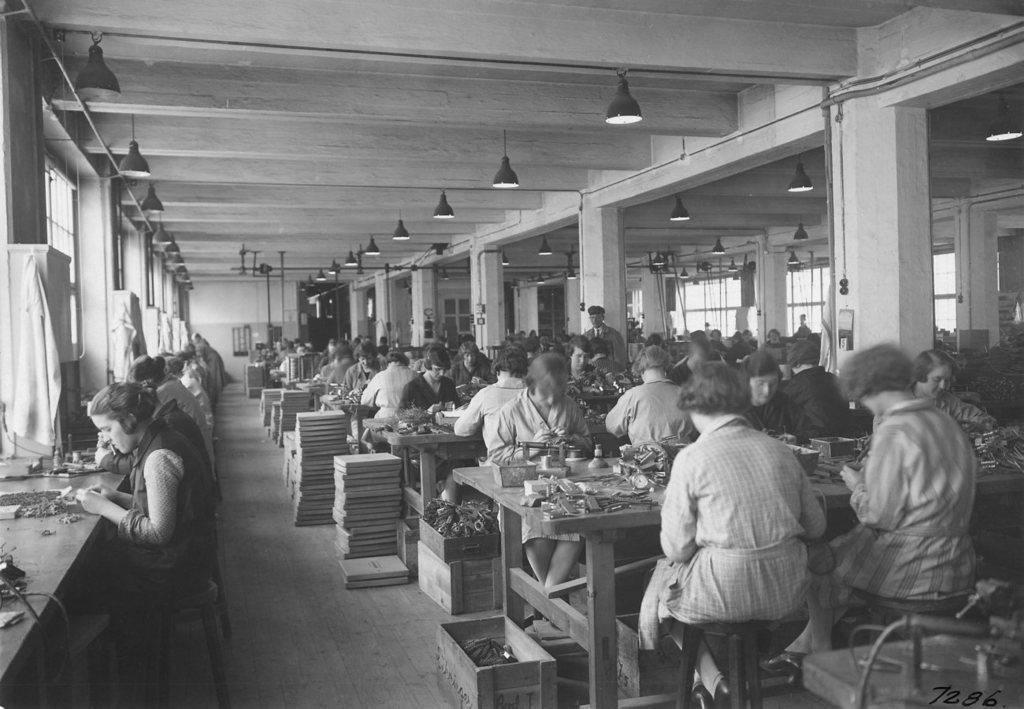What are the people in the image doing? The people in the image are sitting on chairs and working on something. Where are the people located in relation to the table? The people are in front of a table. What can be seen on the roof in the image? There are lamps on the roof in the image. What news is being discussed by the people in the image? There is no indication in the image that the people are discussing any news. What surprise is being revealed by the people in the image? There is no indication in the image that a surprise is being revealed by the people. 